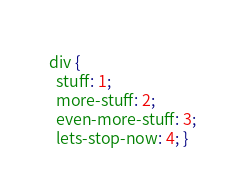Convert code to text. <code><loc_0><loc_0><loc_500><loc_500><_CSS_>div {
  stuff: 1;
  more-stuff: 2;
  even-more-stuff: 3;
  lets-stop-now: 4; }
</code> 